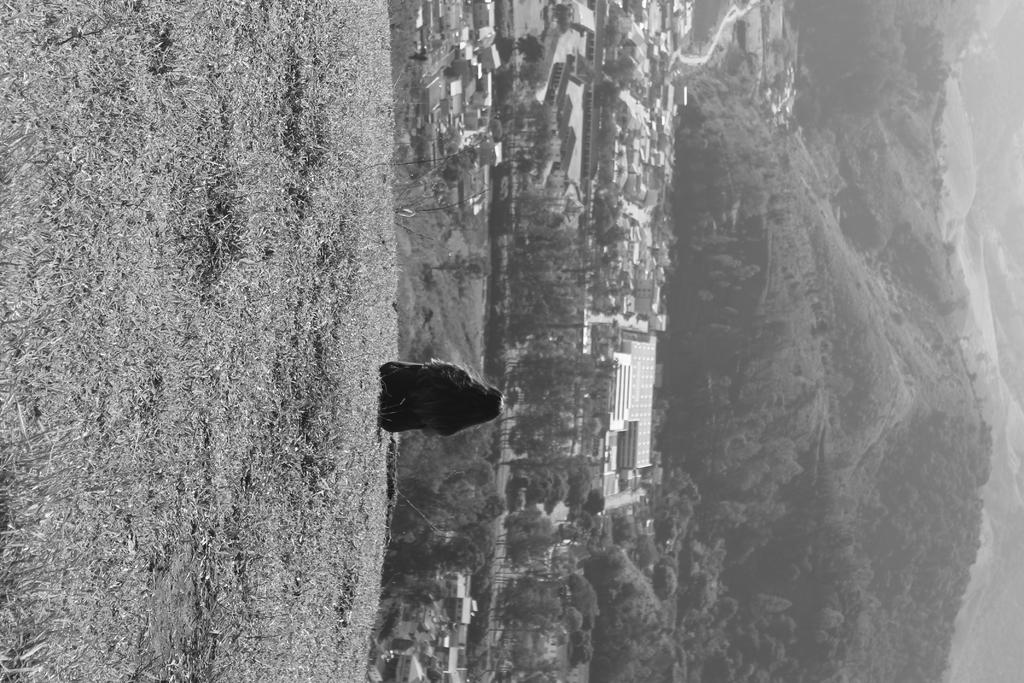Who is the main subject in the image? There is a small girl in the image. What is the girl doing in the image? The girl is sitting on the grass lawn. What can be seen in the background of the image? There are houses and mountains visible in the background of the image. What is visible in the sky in the image? The sky is visible in the image, and clouds are present. What is the girl arguing about with her brothers in the image? There is no mention of brothers or an argument in the image; it only features a small girl sitting on the grass lawn. 